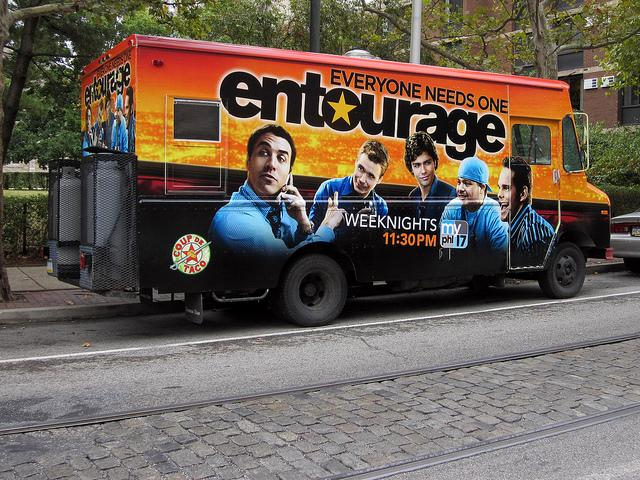Why does the van have a realistic photo on the side?

Choices:
A) by law
B) advertising
C) for fun
D) for aesthetics advertising 